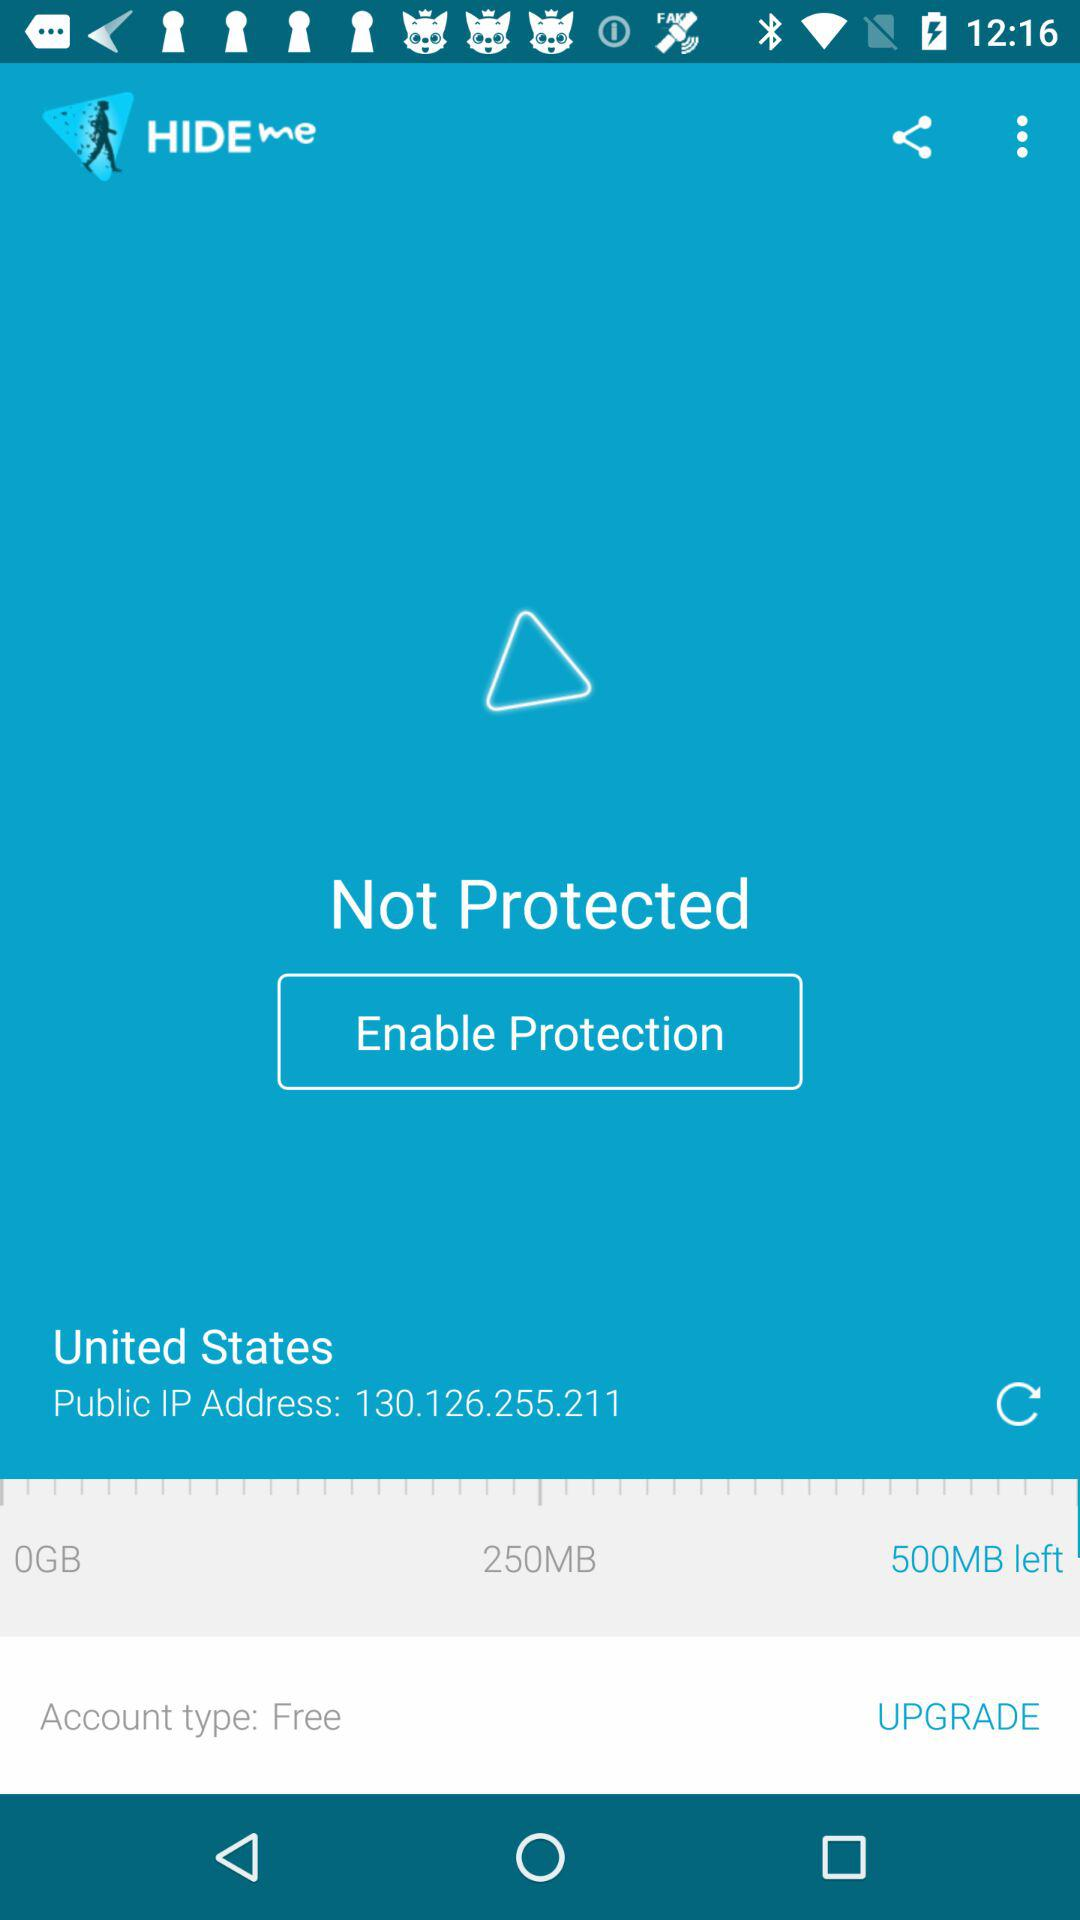How much MB is left? There are 500 MB left. 